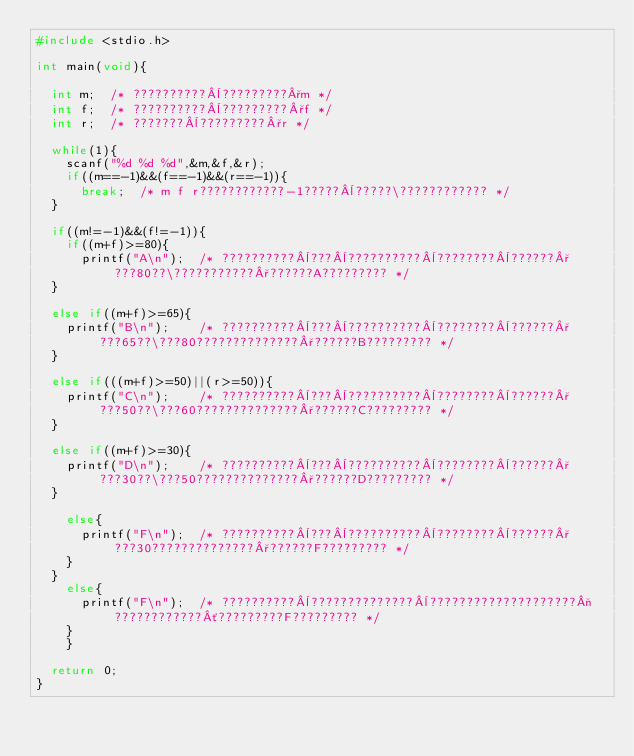Convert code to text. <code><loc_0><loc_0><loc_500><loc_500><_C_>#include <stdio.h>
 
int main(void){

	int m;	/* ??????????¨?????????°m */
	int f;	/* ??????????¨?????????°f */
	int r;	/* ???????¨?????????°r */

	while(1){
		scanf("%d %d %d",&m,&f,&r);
		if((m==-1)&&(f==-1)&&(r==-1)){
			break;	/* m f r????????????-1?????¨?????\???????????? */
	}

	if((m!=-1)&&(f!=-1)){
		if((m+f)>=80){
			printf("A\n");	/* ??????????¨???¨??????????¨????????¨??????°???80??\???????????°??????A????????? */
	}

	else if((m+f)>=65){
		printf("B\n");		/* ??????????¨???¨??????????¨????????¨??????°???65??\???80??????????????°??????B????????? */
	}

	else if(((m+f)>=50)||(r>=50)){
		printf("C\n");		/* ??????????¨???¨??????????¨????????¨??????°???50??\???60??????????????°??????C????????? */
	}

	else if((m+f)>=30){
		printf("D\n");		/* ??????????¨???¨??????????¨????????¨??????°???30??\???50??????????????°??????D????????? */
	}

		else{
			printf("F\n");	/* ??????????¨???¨??????????¨????????¨??????°???30??????????????°??????F????????? */
		}
	}
		else{
			printf("F\n");	/* ??????????¨??????????????¨????????????????????¬????????????´?????????F????????? */
		}
    }

	return 0;
}</code> 